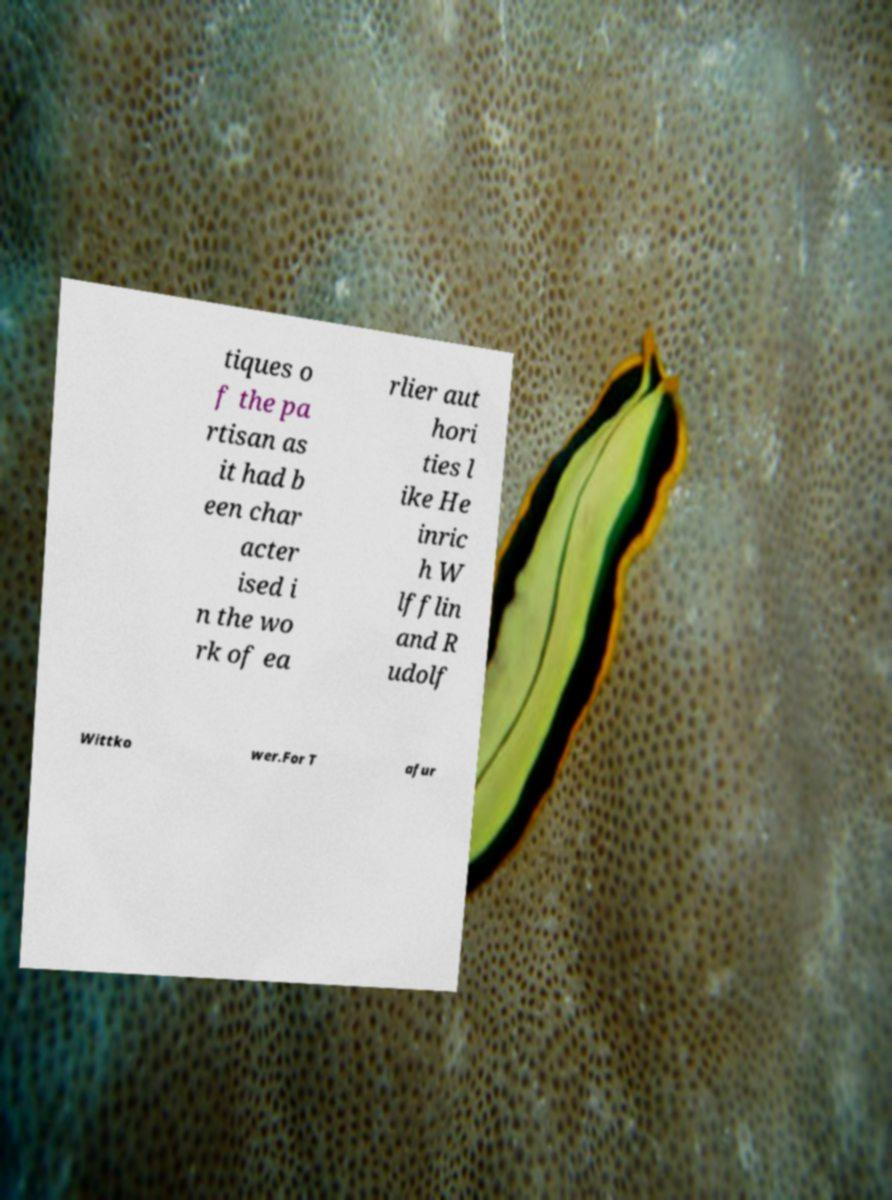Could you assist in decoding the text presented in this image and type it out clearly? tiques o f the pa rtisan as it had b een char acter ised i n the wo rk of ea rlier aut hori ties l ike He inric h W lfflin and R udolf Wittko wer.For T afur 